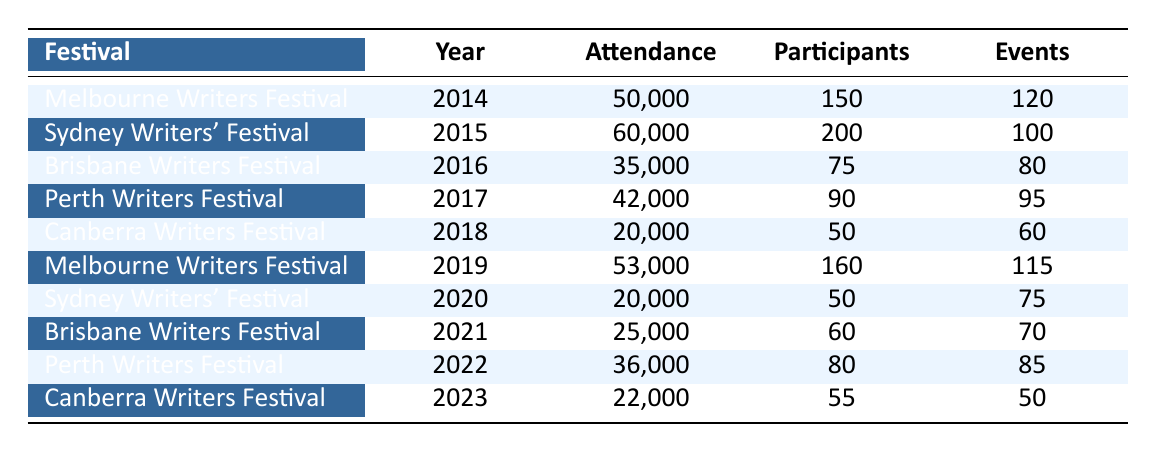What was the highest attendance recorded in the festivals? The attendance values are 50000, 60000, 35000, 42000, 20000, 53000, 20000, 25000, 36000, and 22000 for the respective years. The maximum attendance value is 60000 recorded in 2015 during the Sydney Writers' Festival.
Answer: 60000 How many participants attended the Melbourne Writers Festival in 2019? The table shows that the Melbourne Writers Festival in 2019 had 160 participants.
Answer: 160 What is the total attendance across all festivals in 2022? The attendance for the festivals in 2022 mainly includes 36000 for Perth Writers Festival. Thus, the total attendance specifically for that festival is 36000, as it is the only event recorded for that year.
Answer: 36000 Did the attendance at the Canberra Writers Festival increase from 2018 to 2023? In 2018, the attendance was 20000, and in 2023, it was 22000. Comparing the two values, 22000 is greater than 20000, so yes, the attendance increased.
Answer: Yes What was the average number of participants across all festivals from 2014 to 2023? Adding the participants gives (150 + 200 + 75 + 90 + 50 + 160 + 50 + 60 + 80 + 55) = 1020. There are 10 data points, so the average number of participants is 1020 divided by 10, which equals 102.
Answer: 102 Which year had the lowest number of events, and what was the count? By examining the events count, the lowest is 50 events in 2023 during the Canberra Writers Festival. Therefore, the year with the lowest events is 2023.
Answer: 2023, 50 How many notable guests were at the Sydney Writers' Festival in 2015? The notable guests for the Sydney Writers' Festival in 2015 are Hannah Arendt, Kate Grenville, and Tim Winton. There are three guests mentioned, so the count is 3.
Answer: 3 Was there a year where the attendance was below 30000? Yes, the data shows the attendance figures of 20000 for Canberra Writers Festival in 2018 and 20000 again for Sydney Writers' Festival in 2020, both of which are below 30000.
Answer: Yes How much did the attendance drop from the Sydney Writers' Festival in 2015 to 2020? The attendance in 2015 was 60000 and dropped to 20000 in 2020. The difference is 60000 - 20000 = 40000.
Answer: 40000 